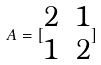Convert formula to latex. <formula><loc_0><loc_0><loc_500><loc_500>A = [ \begin{matrix} 2 & 1 \\ 1 & 2 \end{matrix} ]</formula> 